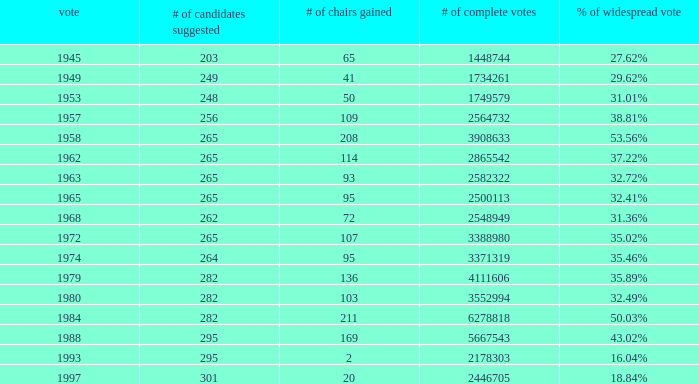What was the lowest # of total votes? 1448744.0. 